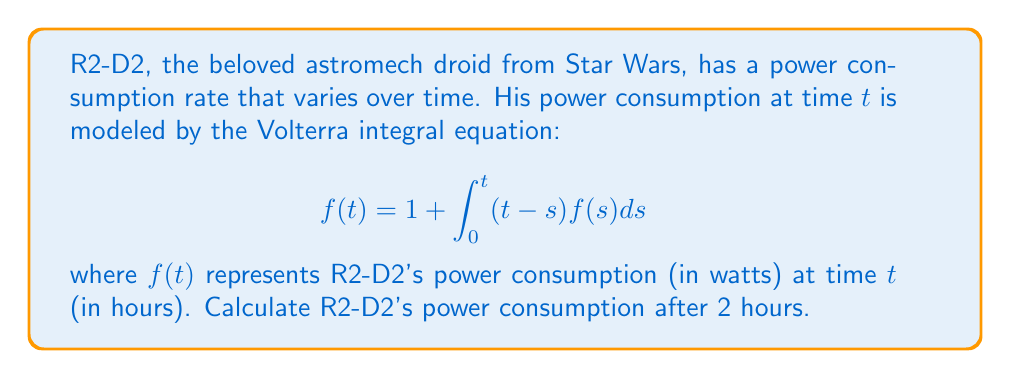Provide a solution to this math problem. To solve this Volterra integral equation, we'll use the method of successive approximations:

1) Start with the initial approximation $f_0(t) = 1$.

2) Substitute this into the integral equation to get the next approximation:

   $$f_1(t) = 1 + \int_0^t (t-s)f_0(s)ds = 1 + \int_0^t (t-s)ds = 1 + \frac{t^2}{2}$$

3) Use $f_1(t)$ to find $f_2(t)$:

   $$f_2(t) = 1 + \int_0^t (t-s)(1 + \frac{s^2}{2})ds = 1 + \frac{t^2}{2} + \frac{t^4}{24}$$

4) Continue this process to get $f_3(t)$:

   $$f_3(t) = 1 + \int_0^t (t-s)(1 + \frac{s^2}{2} + \frac{s^4}{24})ds = 1 + \frac{t^2}{2} + \frac{t^4}{24} + \frac{t^6}{720}$$

5) We can see the pattern forming. The exact solution is the sum of this infinite series:

   $$f(t) = 1 + \frac{t^2}{2!} + \frac{t^4}{4!} + \frac{t^6}{6!} + ...$$

6) This series is recognized as the hyperbolic cosine function:

   $$f(t) = \cosh(t)$$

7) To find R2-D2's power consumption after 2 hours, we calculate $\cosh(2)$:

   $$f(2) = \cosh(2) \approx 3.7622$$

Therefore, R2-D2's power consumption after 2 hours is approximately 3.7622 watts.
Answer: $3.7622$ watts 